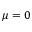<formula> <loc_0><loc_0><loc_500><loc_500>\mu = 0</formula> 